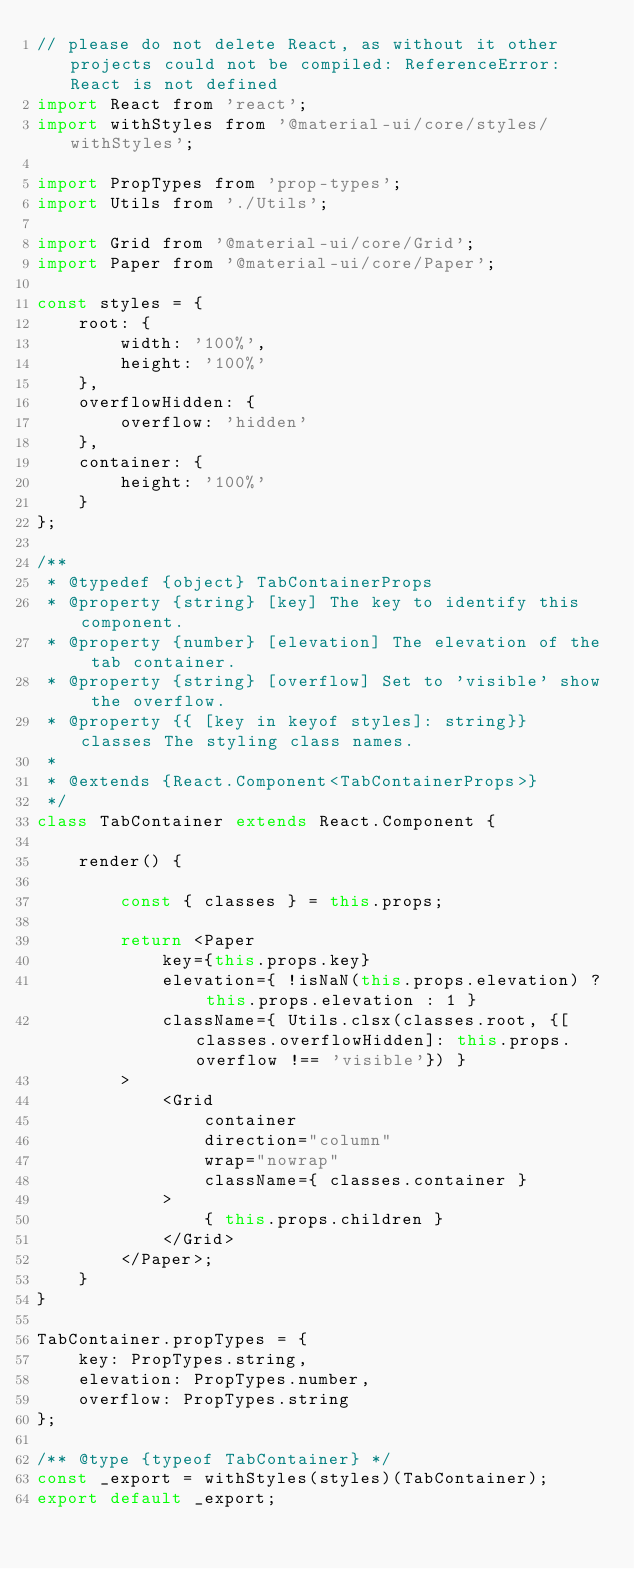Convert code to text. <code><loc_0><loc_0><loc_500><loc_500><_JavaScript_>// please do not delete React, as without it other projects could not be compiled: ReferenceError: React is not defined
import React from 'react';
import withStyles from '@material-ui/core/styles/withStyles';

import PropTypes from 'prop-types';
import Utils from './Utils';

import Grid from '@material-ui/core/Grid';
import Paper from '@material-ui/core/Paper';

const styles = {
    root: {
        width: '100%',
        height: '100%'
    },
    overflowHidden: {
        overflow: 'hidden'
    },
    container: {
        height: '100%'
    }
};

/**
 * @typedef {object} TabContainerProps
 * @property {string} [key] The key to identify this component.
 * @property {number} [elevation] The elevation of the tab container.
 * @property {string} [overflow] Set to 'visible' show the overflow.
 * @property {{ [key in keyof styles]: string}} classes The styling class names.
 *
 * @extends {React.Component<TabContainerProps>}
 */
class TabContainer extends React.Component {

    render() {

        const { classes } = this.props;

        return <Paper
            key={this.props.key}
            elevation={ !isNaN(this.props.elevation) ? this.props.elevation : 1 }
            className={ Utils.clsx(classes.root, {[classes.overflowHidden]: this.props.overflow !== 'visible'}) }
        >
            <Grid
                container
                direction="column"
                wrap="nowrap"
                className={ classes.container }
            >
                { this.props.children }
            </Grid>
        </Paper>;
    }
}

TabContainer.propTypes = {
    key: PropTypes.string,
    elevation: PropTypes.number,
    overflow: PropTypes.string
};

/** @type {typeof TabContainer} */
const _export = withStyles(styles)(TabContainer);
export default _export;</code> 